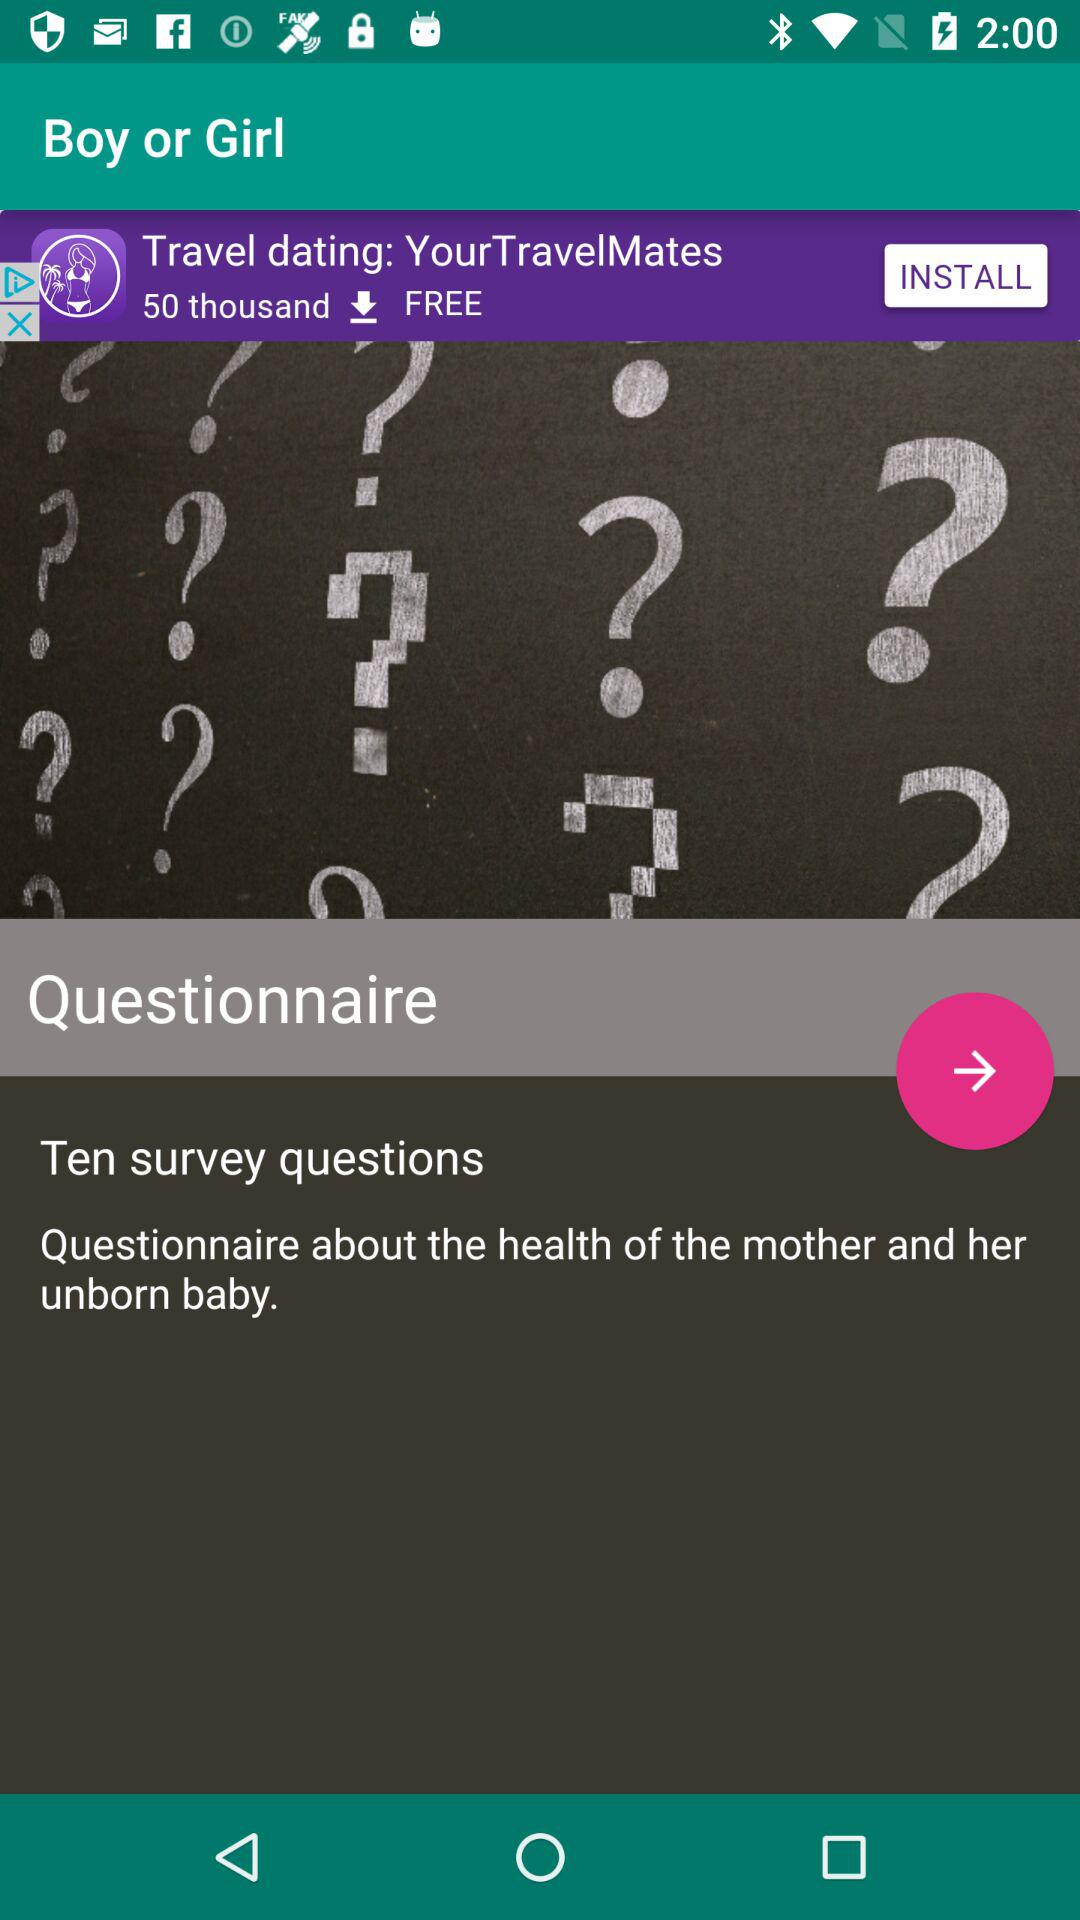What is the name of the application? The name of the application is "Boy or Girl". 